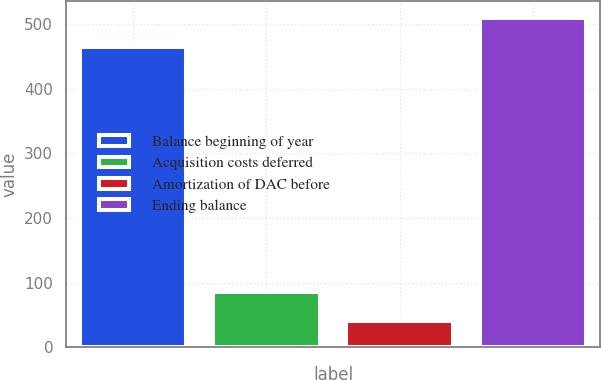Convert chart to OTSL. <chart><loc_0><loc_0><loc_500><loc_500><bar_chart><fcel>Balance beginning of year<fcel>Acquisition costs deferred<fcel>Amortization of DAC before<fcel>Ending balance<nl><fcel>465<fcel>85.8<fcel>41<fcel>509.8<nl></chart> 